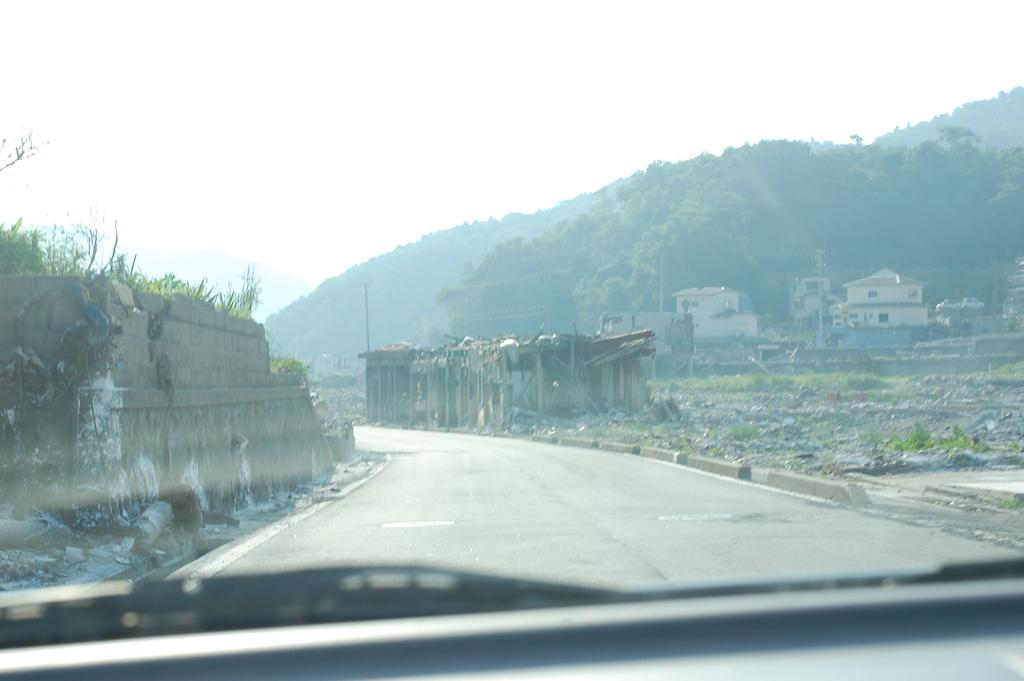What is located at the bottom side of the image? There is a car at the bottom side of the image. What type of structures can be seen in the image? There are houses in the image. What type of vegetation is present in the image? There are trees in the image. What type of damage can be observed in the image? There are broken walls in the image. What type of sign is visible on the car in the image? There is no sign visible on the car in the image. 